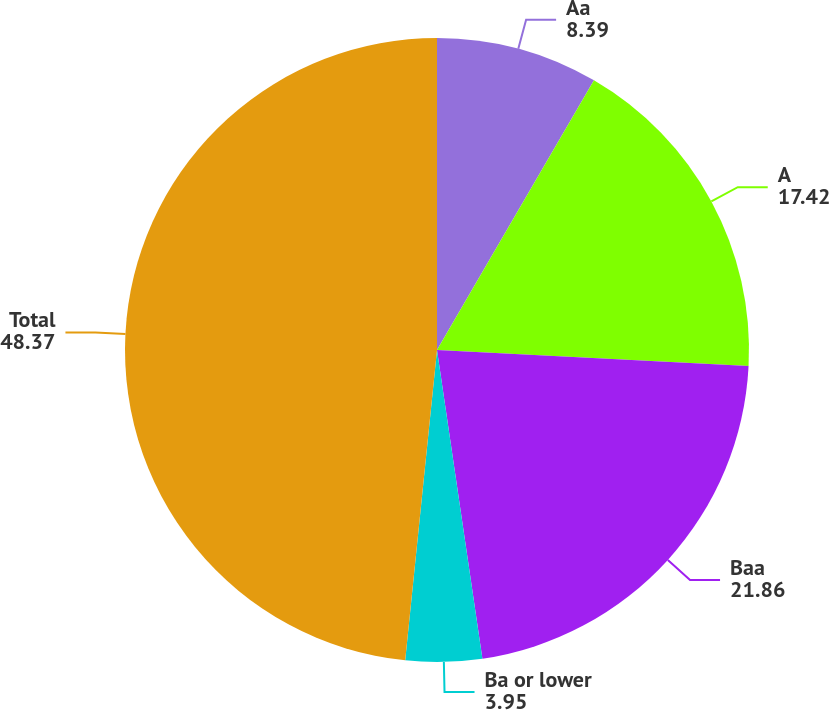Convert chart. <chart><loc_0><loc_0><loc_500><loc_500><pie_chart><fcel>Aa<fcel>A<fcel>Baa<fcel>Ba or lower<fcel>Total<nl><fcel>8.39%<fcel>17.42%<fcel>21.86%<fcel>3.95%<fcel>48.37%<nl></chart> 